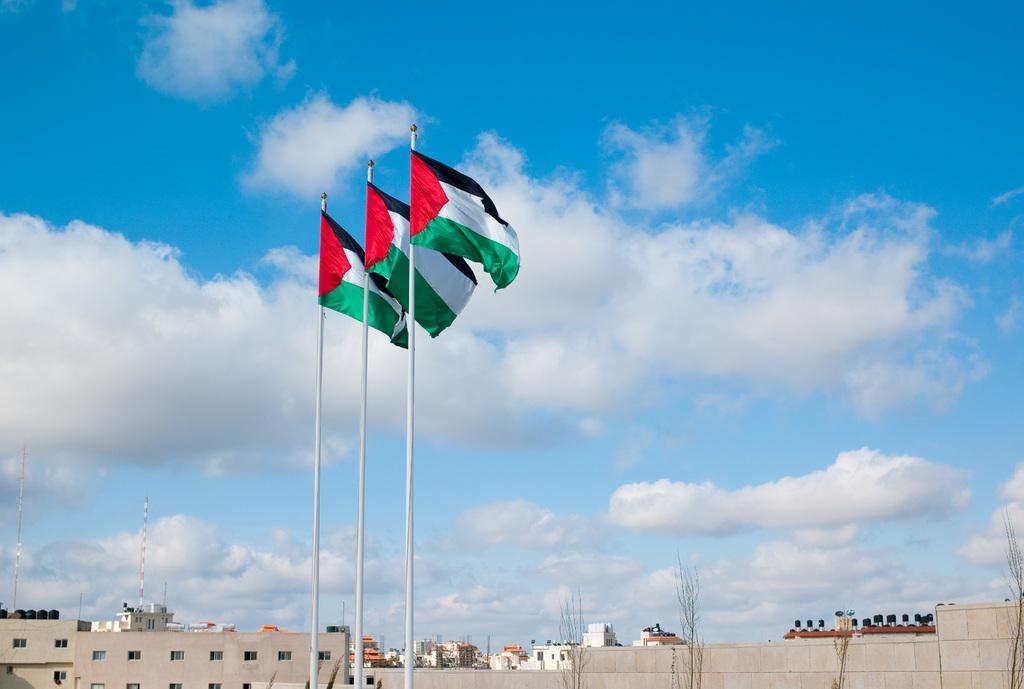What is located in the middle of the image? There are three flags in the middle of the image. What can be seen in the background of the image? There are buildings, trees, houses, and an electric pole in the background of the image. What is visible at the top of the image? The sky is visible at the top of the image. Can you describe the activity of the deer in the image? There are no deer present in the image. How many bikes can be seen in the image? There are no bikes visible in the image. 